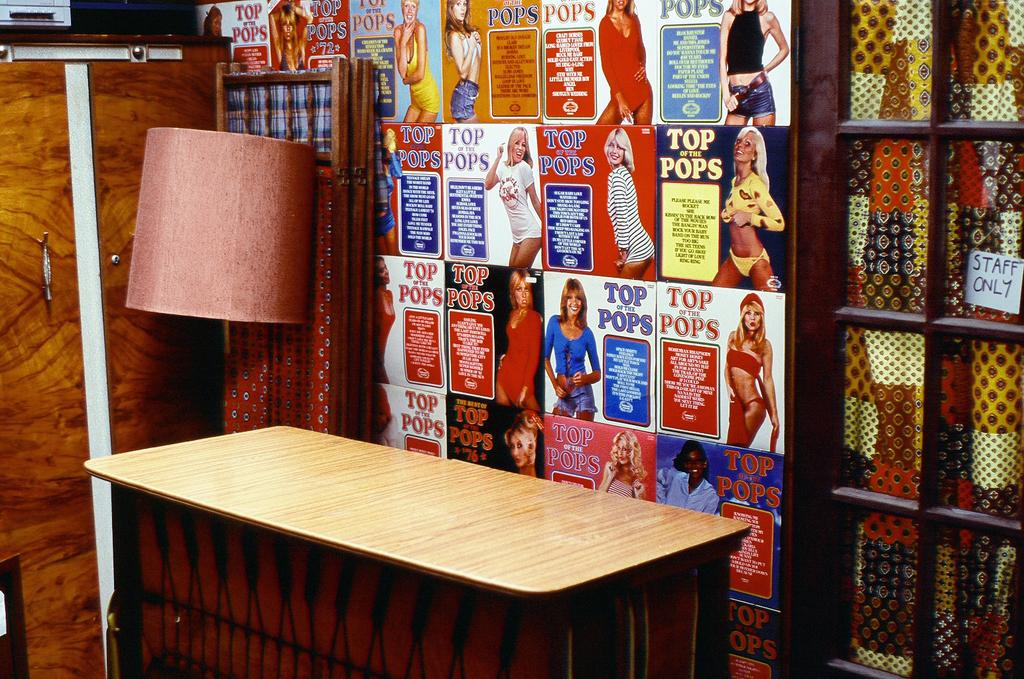Provide a one-sentence caption for the provided image. Several advertisements for top of the pops iare lined up on a wall. 